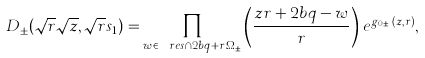Convert formula to latex. <formula><loc_0><loc_0><loc_500><loc_500>D _ { \pm } ( \sqrt { r } \sqrt { z } , \sqrt { r } s _ { 1 } ) = \prod _ { w \in \ r e s \cap 2 b q + r \Omega _ { \pm } } \left ( \frac { z r + 2 b q - w } { r } \right ) \, e ^ { g _ { 0 , \pm } ( z , r ) } ,</formula> 